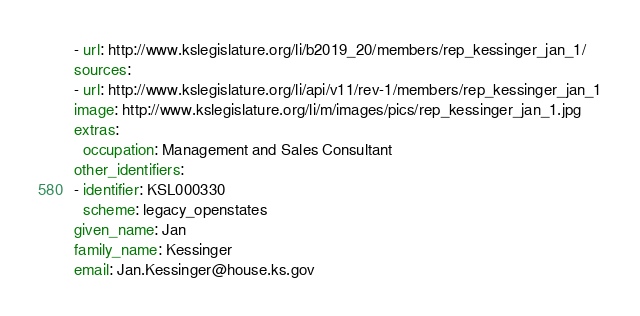<code> <loc_0><loc_0><loc_500><loc_500><_YAML_>- url: http://www.kslegislature.org/li/b2019_20/members/rep_kessinger_jan_1/
sources:
- url: http://www.kslegislature.org/li/api/v11/rev-1/members/rep_kessinger_jan_1
image: http://www.kslegislature.org/li/m/images/pics/rep_kessinger_jan_1.jpg
extras:
  occupation: Management and Sales Consultant
other_identifiers:
- identifier: KSL000330
  scheme: legacy_openstates
given_name: Jan
family_name: Kessinger
email: Jan.Kessinger@house.ks.gov
</code> 